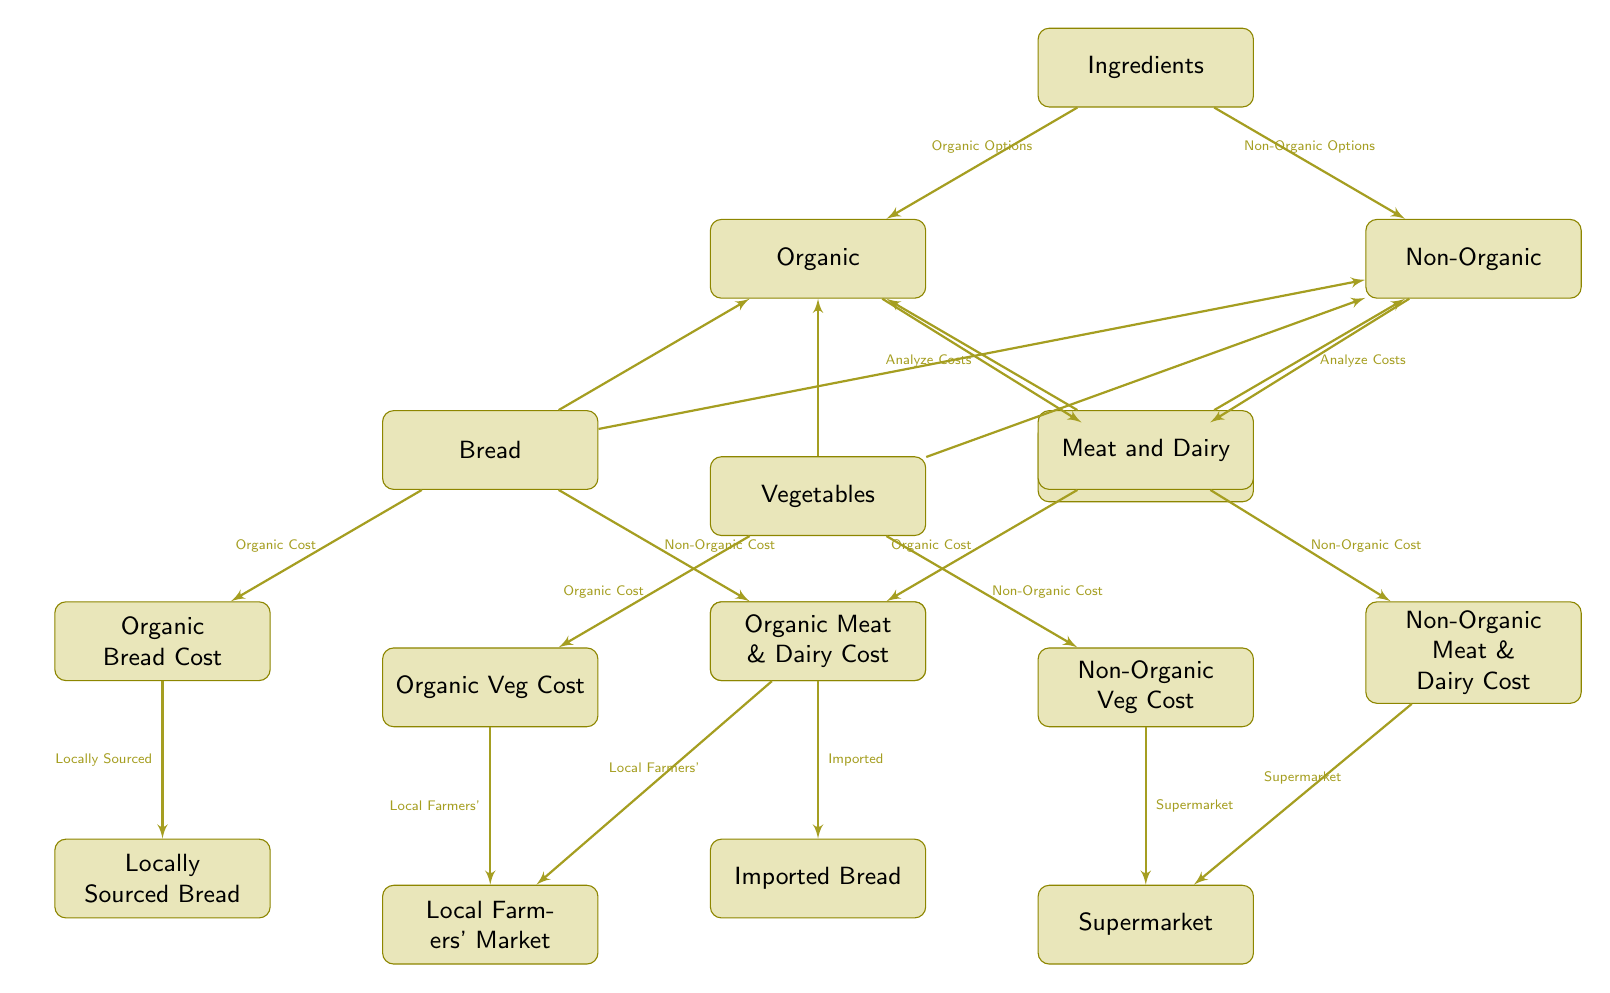What are the two main categories of ingredients in the diagram? The diagram categorizes ingredients into two main types: Organic and Non-Organic. These categories are directly linked to the initial node labeled "Ingredients."
Answer: Organic and Non-Organic How many types of ingredients are analyzed for cost? There are three types of ingredients analyzed for cost: Bread, Vegetables, and Meat and Dairy. Each type is shown as a separate node branching from the Organic and Non-Organic categories.
Answer: Three What is the cost source for Organic Bread? The cost source for Organic Bread is identified as Locally Sourced Bread, which is linked to the Organic Bread Cost node.
Answer: Locally Sourced Bread Which market is associated with Non-Organic Vegetables? Non-Organic Vegetables are associated with the Supermarket, as indicated by the connection from the Non-Organic Veg Cost node.
Answer: Supermarket Which option has more cost nodes? The diagram has an equal number of cost nodes for both Organic and Non-Organic options, with each ingredient type having one Organic and one Non-Organic cost node, totaling to six nodes for each category.
Answer: Equal What is the relationship between Organic Ingredients and Cost Analysis? Organic Ingredients lead to a sub-node labeled Cost Analysis, indicating that costs are analyzed for the ingredients classified as organic. This relationship helps evaluate their expenses separately.
Answer: Analyze Costs Where do both Organic and Non-Organic Meat & Dairy costs derive from? Both Organic and Non-Organic Meat & Dairy costs derive from specific sources: Organic Meat & Dairy from Local Farmers', and Non-Organic from Supermarket, as indicated by their respective connections in the diagram.
Answer: Local Farmers' & Supermarket How many total edges are there in the diagram? Counting the edges, we have 12 connections total within the diagram that illustrate the relationships between different ingredient categories, costs, and their sources.
Answer: Twelve 